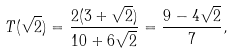Convert formula to latex. <formula><loc_0><loc_0><loc_500><loc_500>T ( \sqrt { 2 } ) = \frac { 2 ( 3 + \sqrt { 2 } ) } { 1 0 + 6 \sqrt { 2 } } = \frac { 9 - 4 \sqrt { 2 } } { 7 } ,</formula> 